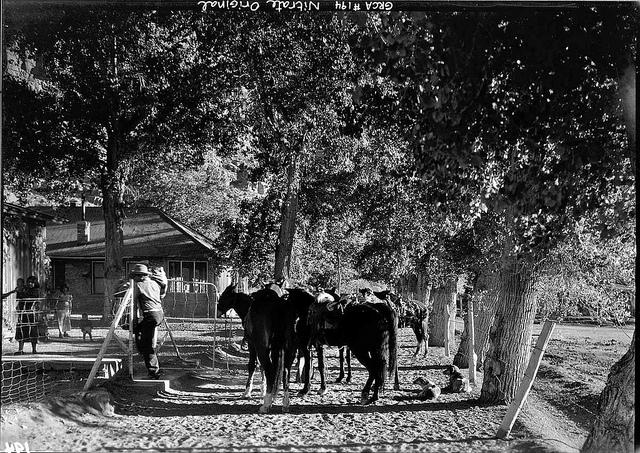What are the animals standing on?
Short answer required. Dirt. What animals are shown?
Quick response, please. Horses. What colors is the cow?
Short answer required. Black. Is the horse pulling a plow?
Quick response, please. No. What kind of trees are in the background?
Write a very short answer. Oak. What animal is in this picture?
Give a very brief answer. Horse. Is there something separating the humans from the animals?
Write a very short answer. No. What kind of animals are these?
Concise answer only. Horses. Would this lifestyle tend to leave a lot time for leisure activity?
Be succinct. No. Is the road well trod?
Give a very brief answer. Yes. Is this a wild animal?
Be succinct. No. How many horses are pictured?
Short answer required. 3. 